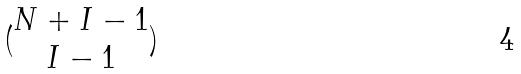<formula> <loc_0><loc_0><loc_500><loc_500>( \begin{matrix} N + I - 1 \\ I - 1 \end{matrix} )</formula> 